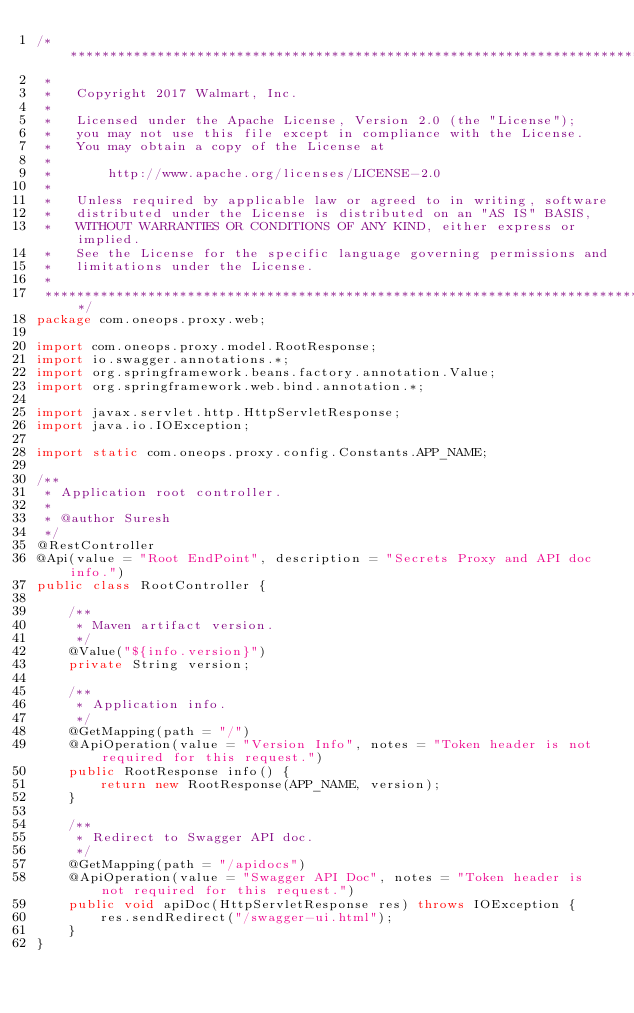<code> <loc_0><loc_0><loc_500><loc_500><_Java_>/*******************************************************************************
 *
 *   Copyright 2017 Walmart, Inc.
 *
 *   Licensed under the Apache License, Version 2.0 (the "License");
 *   you may not use this file except in compliance with the License.
 *   You may obtain a copy of the License at
 *
 *       http://www.apache.org/licenses/LICENSE-2.0
 *
 *   Unless required by applicable law or agreed to in writing, software
 *   distributed under the License is distributed on an "AS IS" BASIS,
 *   WITHOUT WARRANTIES OR CONDITIONS OF ANY KIND, either express or implied.
 *   See the License for the specific language governing permissions and
 *   limitations under the License.
 *
 *******************************************************************************/
package com.oneops.proxy.web;

import com.oneops.proxy.model.RootResponse;
import io.swagger.annotations.*;
import org.springframework.beans.factory.annotation.Value;
import org.springframework.web.bind.annotation.*;

import javax.servlet.http.HttpServletResponse;
import java.io.IOException;

import static com.oneops.proxy.config.Constants.APP_NAME;

/**
 * Application root controller.
 *
 * @author Suresh
 */
@RestController
@Api(value = "Root EndPoint", description = "Secrets Proxy and API doc info.")
public class RootController {

    /**
     * Maven artifact version.
     */
    @Value("${info.version}")
    private String version;

    /**
     * Application info.
     */
    @GetMapping(path = "/")
    @ApiOperation(value = "Version Info", notes = "Token header is not required for this request.")
    public RootResponse info() {
        return new RootResponse(APP_NAME, version);
    }

    /**
     * Redirect to Swagger API doc.
     */
    @GetMapping(path = "/apidocs")
    @ApiOperation(value = "Swagger API Doc", notes = "Token header is not required for this request.")
    public void apiDoc(HttpServletResponse res) throws IOException {
        res.sendRedirect("/swagger-ui.html");
    }
}
</code> 